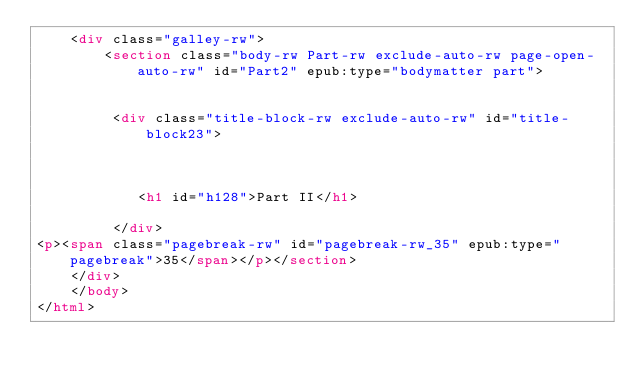<code> <loc_0><loc_0><loc_500><loc_500><_HTML_>	<div class="galley-rw">
		<section class="body-rw Part-rw exclude-auto-rw page-open-auto-rw" id="Part2" epub:type="bodymatter part">


         <div class="title-block-rw exclude-auto-rw" id="title-block23">



            <h1 id="h128">Part II</h1>

         </div>
<p><span class="pagebreak-rw" id="pagebreak-rw_35" epub:type="pagebreak">35</span></p></section>
	</div>
    </body>
</html>
</code> 